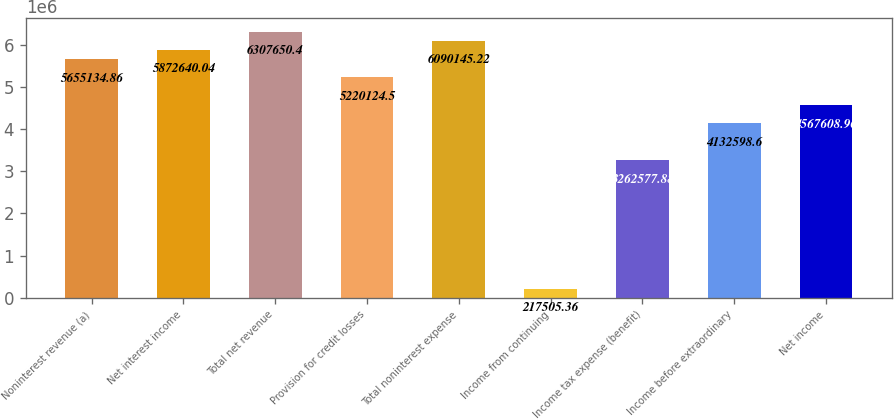Convert chart to OTSL. <chart><loc_0><loc_0><loc_500><loc_500><bar_chart><fcel>Noninterest revenue (a)<fcel>Net interest income<fcel>Total net revenue<fcel>Provision for credit losses<fcel>Total noninterest expense<fcel>Income from continuing<fcel>Income tax expense (benefit)<fcel>Income before extraordinary<fcel>Net income<nl><fcel>5.65513e+06<fcel>5.87264e+06<fcel>6.30765e+06<fcel>5.22012e+06<fcel>6.09015e+06<fcel>217505<fcel>3.26258e+06<fcel>4.1326e+06<fcel>4.56761e+06<nl></chart> 